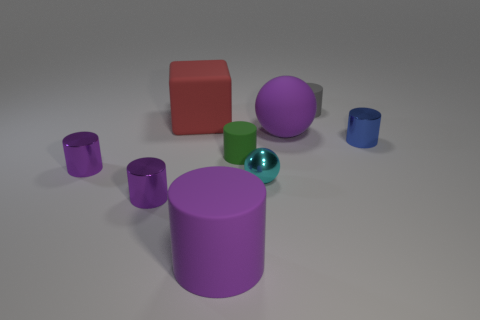What color is the other tiny cylinder that is made of the same material as the green cylinder?
Your response must be concise. Gray. There is a purple matte object that is right of the green object; is there a gray rubber cylinder that is in front of it?
Your answer should be compact. No. What is the color of the ball that is the same size as the gray object?
Offer a terse response. Cyan. How many objects are either cyan matte blocks or large things?
Offer a terse response. 3. What is the size of the cyan metal object that is on the left side of the metal cylinder on the right side of the small rubber cylinder behind the red object?
Give a very brief answer. Small. How many tiny metal things have the same color as the large rubber cylinder?
Offer a very short reply. 2. How many tiny blue cylinders have the same material as the large purple cylinder?
Give a very brief answer. 0. How many objects are gray matte cylinders or big objects that are in front of the purple sphere?
Your answer should be compact. 2. There is a big object on the left side of the large purple object on the left side of the big purple object behind the big cylinder; what color is it?
Your response must be concise. Red. There is a ball in front of the large purple matte sphere; how big is it?
Provide a succinct answer. Small. 